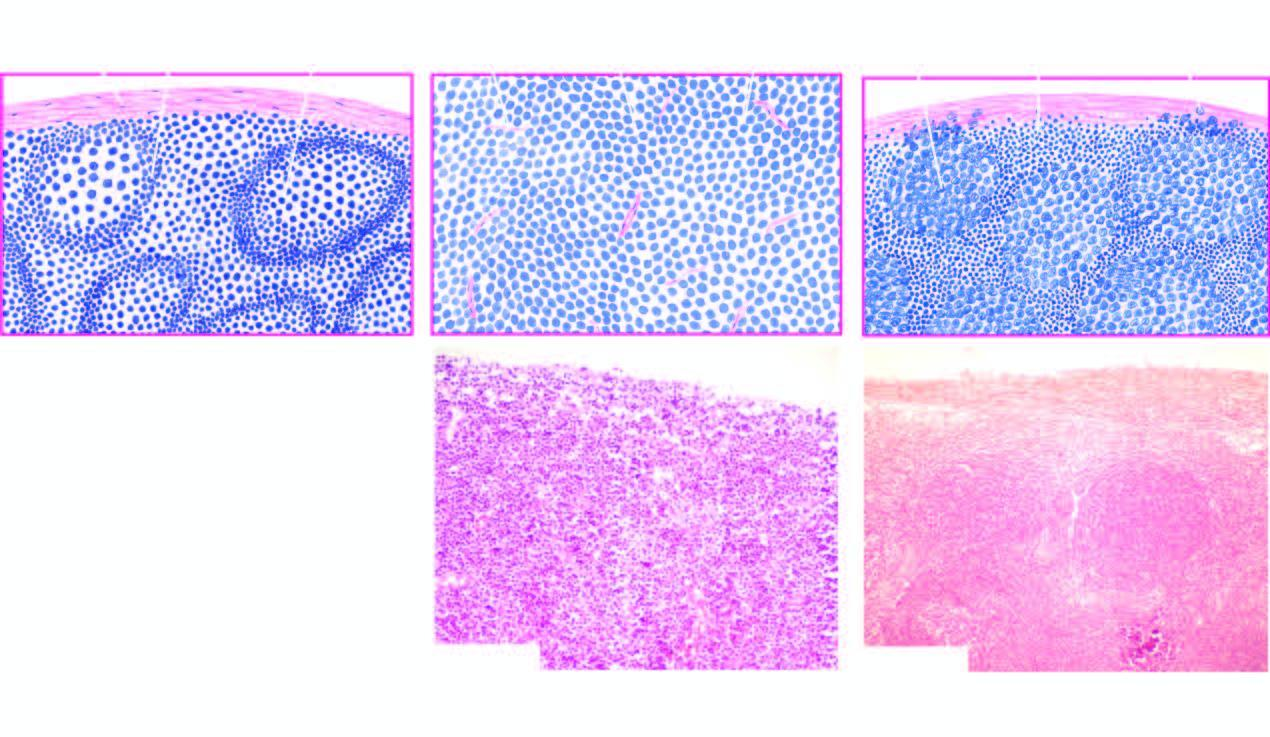s follicular lymphoma contrasted with structure of normal lymph node a?
Answer the question using a single word or phrase. Yes 